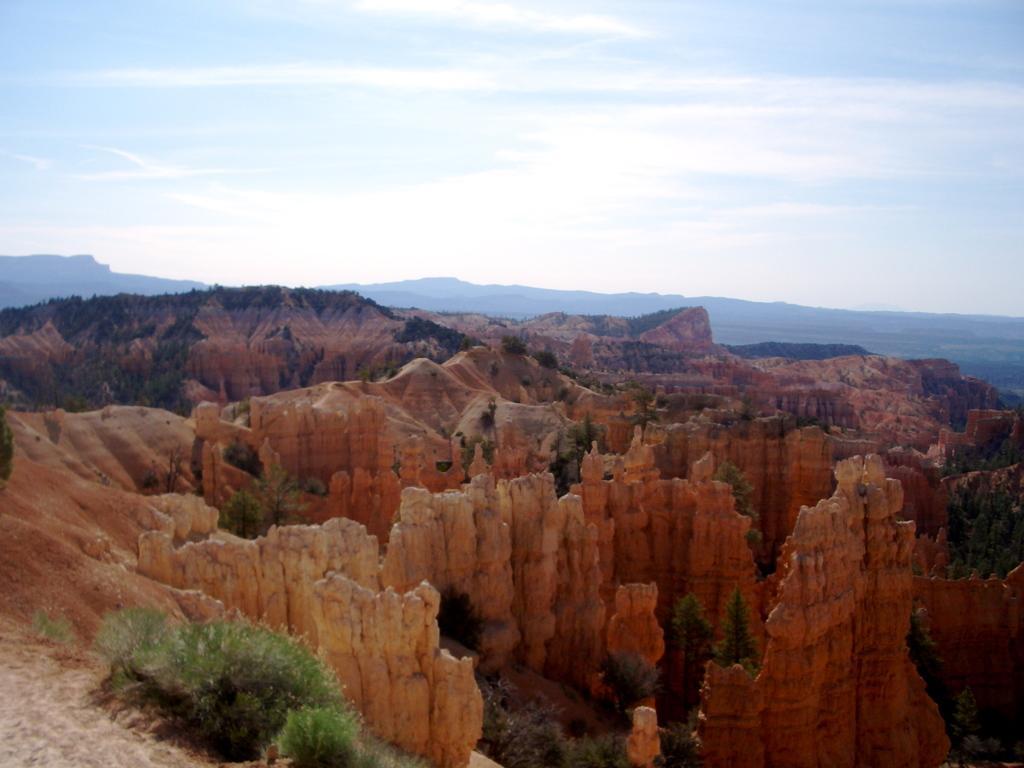Please provide a concise description of this image. In this image we can see a few red dunes, trees, plants and the mountains, in the background, we can see the sky with clouds. 